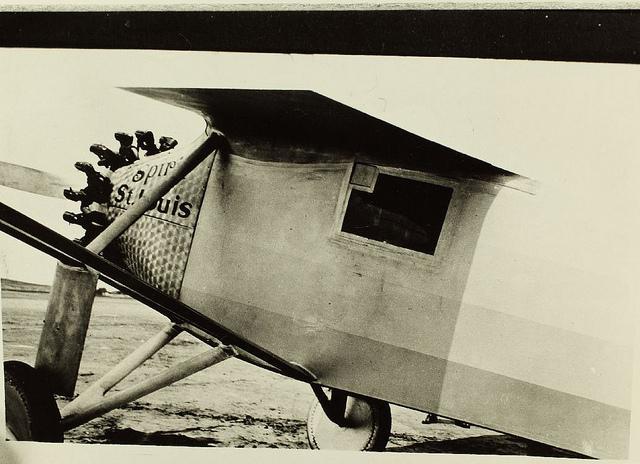Are any people present?
Quick response, please. No. What  is the name of this airplane?
Answer briefly. Spirit of st louis. What is the plane doing on the beach?
Short answer required. Landing. 